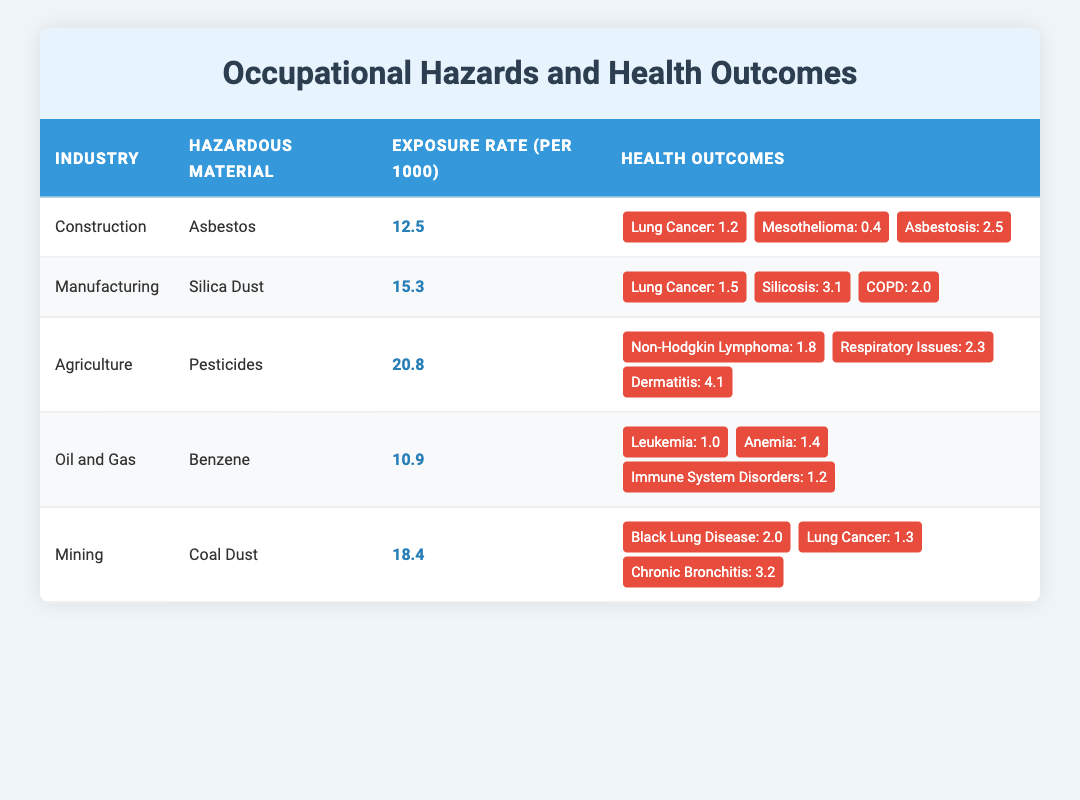What is the exposure rate for the Agriculture industry? The exposure rate for the Agriculture industry, according to the table, is listed under the "Exposure Rate (per 1000)" column for that industry, which is 20.8.
Answer: 20.8 Which hazardous material is associated with the Mining industry? In the table, the hazardous material associated with the Mining industry is found in the "Hazardous Material" column, which states "Coal Dust."
Answer: Coal Dust True or False: The exposure rate to Pesticides in Agriculture is higher than the exposure rate to Silica Dust in Manufacturing. To determine this, compare the exposure rates: Agriculture (20.8) and Manufacturing (15.3). Since 20.8 is greater than 15.3, the statement is true.
Answer: True What are the total health outcomes related to Asbestos in Construction? The health outcomes related to Asbestos can be found in the "Health Outcomes" column for Construction, which lists Lung Cancer (1.2), Mesothelioma (0.4), and Asbestosis (2.5). The total is 1.2 + 0.4 + 2.5 = 4.1.
Answer: 4.1 Which industry has the highest exposure rate and what is that rate? To find this, we look at the "Exposure Rate (per 1000)" for all industries. Checking each rate: Construction (12.5), Manufacturing (15.3), Agriculture (20.8), Oil and Gas (10.9), Mining (18.4). The highest is Agriculture with 20.8.
Answer: Agriculture, 20.8 What is the average exposure rate across all industries listed? To calculate the average exposure rate, we first sum all the exposure rates: 12.5 + 15.3 + 20.8 + 10.9 + 18.4 = 77.9. There are 5 industries, so the average is 77.9 / 5 = 15.58.
Answer: 15.58 True or False: The health outcome with the highest rate in Agriculture is associated with respiratory issues. Looking at the "Health Outcomes" for Agriculture, the values are Non-Hodgkin Lymphoma (1.8), Respiratory Issues (2.3), and Dermatitis (4.1). Since 4.1 (Dermatitis) is higher than 2.3, the statement is false.
Answer: False If a worker in Mining has a 10% chance of developing Black Lung Disease and the exposure rate is 18.4 per 1000, how many workers are expected to develop Black Lung Disease? The number of expected cases can be calculated by taking the exposure rate (18.4) and multiplying it by the chance of developing the disease (10%, or 0.1): 18.4 * 0.1 = 1.84. Hence, approximately 1.84 workers per 1000 are expected to develop the disease.
Answer: 1.84 